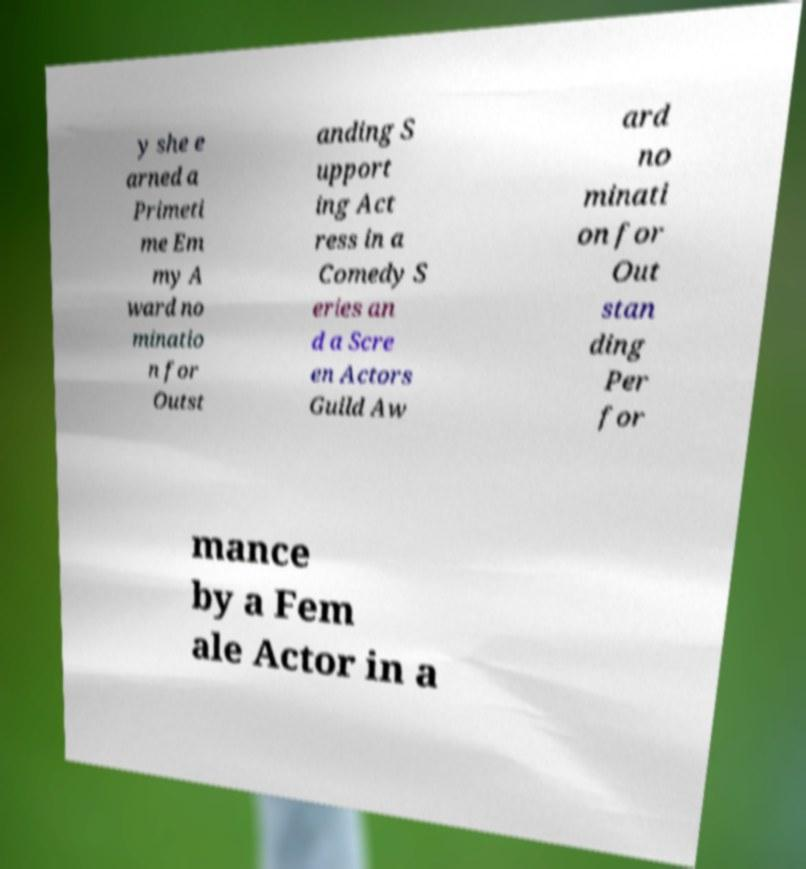Could you assist in decoding the text presented in this image and type it out clearly? y she e arned a Primeti me Em my A ward no minatio n for Outst anding S upport ing Act ress in a Comedy S eries an d a Scre en Actors Guild Aw ard no minati on for Out stan ding Per for mance by a Fem ale Actor in a 